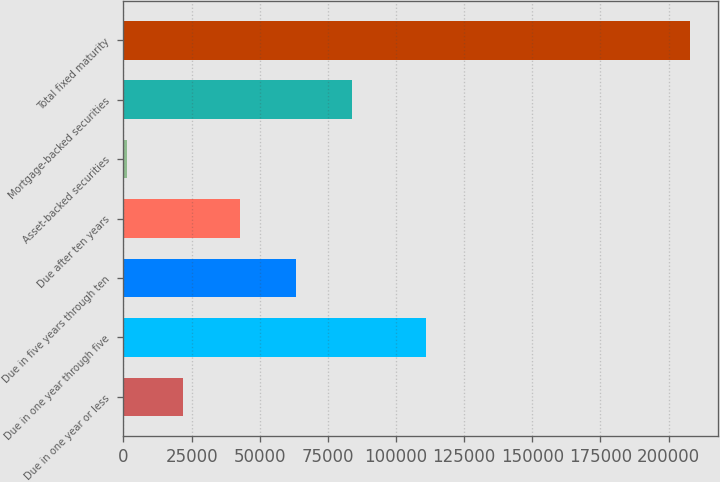<chart> <loc_0><loc_0><loc_500><loc_500><bar_chart><fcel>Due in one year or less<fcel>Due in one year through five<fcel>Due in five years through ten<fcel>Due after ten years<fcel>Asset-backed securities<fcel>Mortgage-backed securities<fcel>Total fixed maturity<nl><fcel>21941.1<fcel>111066<fcel>63251.3<fcel>42596.2<fcel>1286<fcel>83906.4<fcel>207837<nl></chart> 